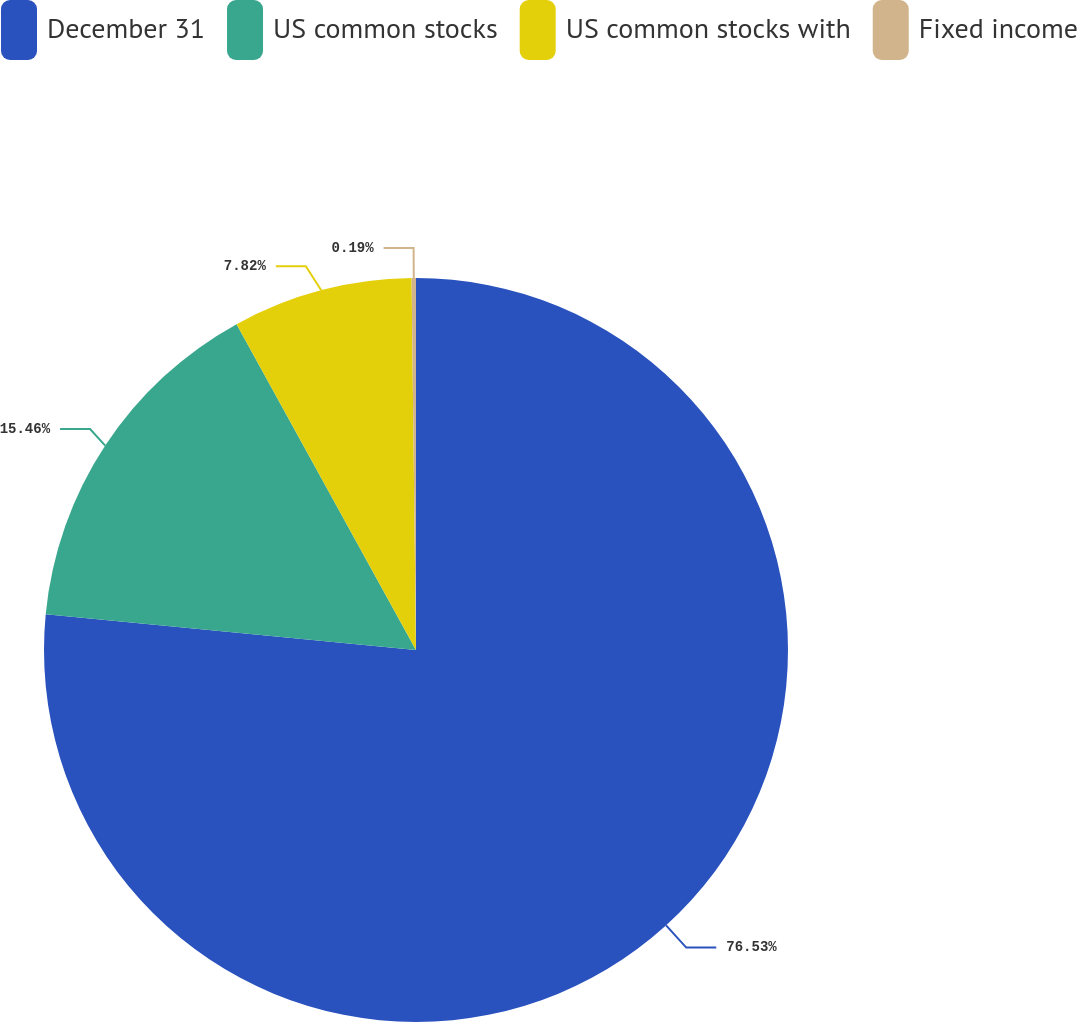Convert chart. <chart><loc_0><loc_0><loc_500><loc_500><pie_chart><fcel>December 31<fcel>US common stocks<fcel>US common stocks with<fcel>Fixed income<nl><fcel>76.53%<fcel>15.46%<fcel>7.82%<fcel>0.19%<nl></chart> 